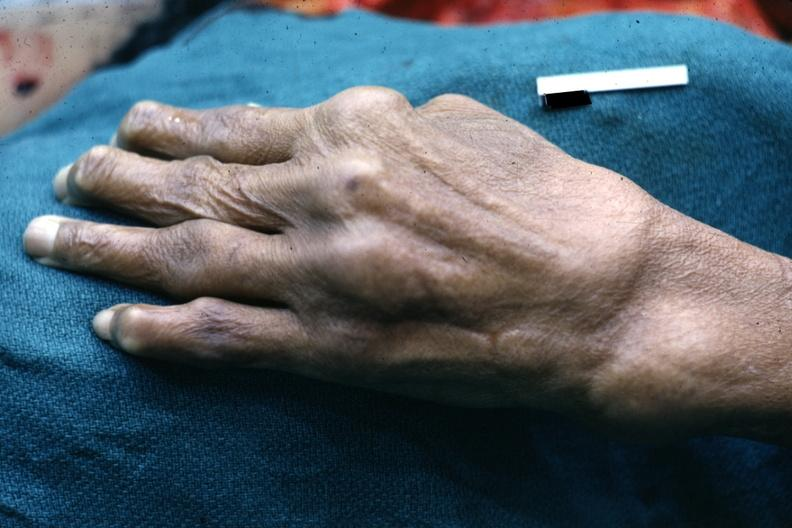what is present?
Answer the question using a single word or phrase. Hand 